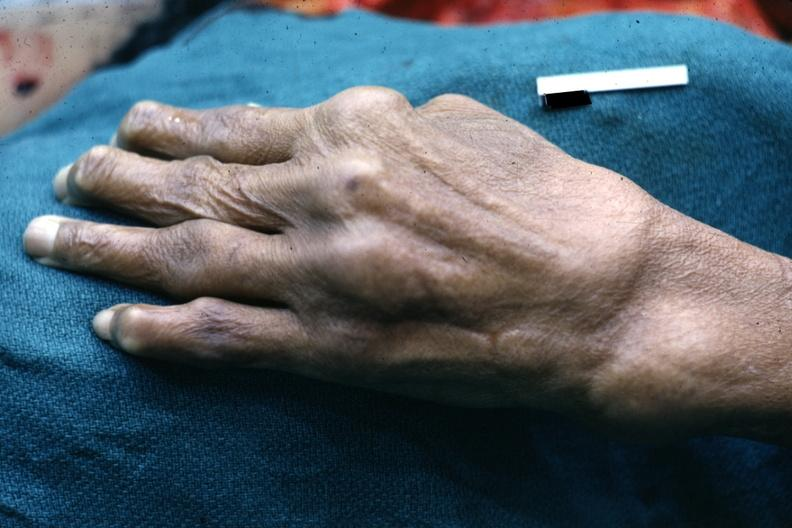what is present?
Answer the question using a single word or phrase. Hand 